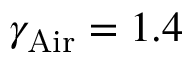<formula> <loc_0><loc_0><loc_500><loc_500>\gamma _ { A i r } = 1 . 4</formula> 